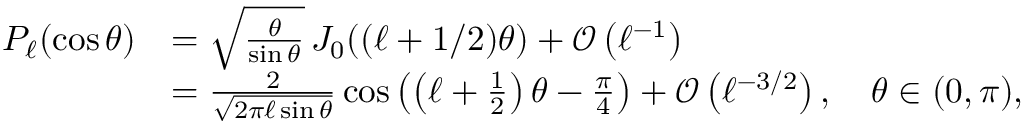Convert formula to latex. <formula><loc_0><loc_0><loc_500><loc_500>{ \begin{array} { r l } { P _ { \ell } ( \cos \theta ) } & { = { \sqrt { \frac { \theta } { \sin \theta } } } \, J _ { 0 } ( ( \ell + 1 / 2 ) \theta ) + { \mathcal { O } } \left ( \ell ^ { - 1 } \right ) } \\ & { = { \frac { 2 } { \sqrt { 2 \pi \ell \sin \theta } } } \cos \left ( \left ( \ell + { \frac { 1 } { 2 } } \right ) \theta - { \frac { \pi } { 4 } } \right ) + { \mathcal { O } } \left ( \ell ^ { - 3 / 2 } \right ) , \quad \theta \in ( 0 , \pi ) , } \end{array} }</formula> 